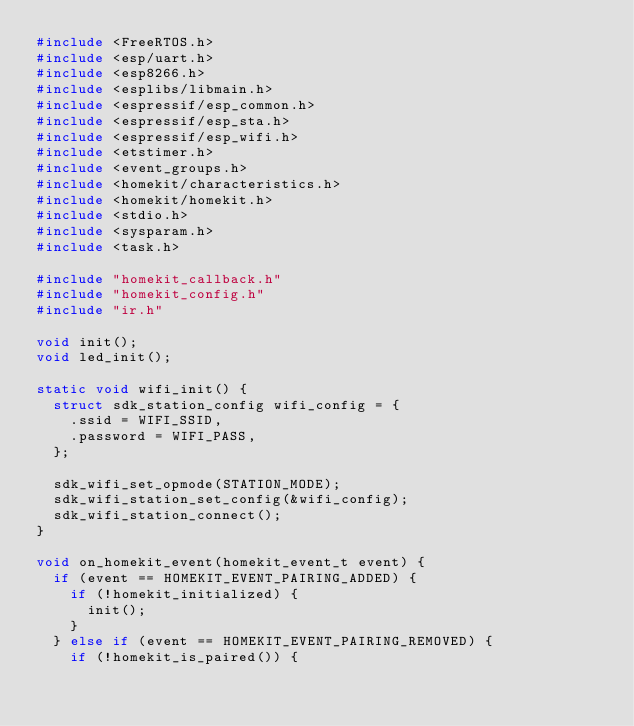<code> <loc_0><loc_0><loc_500><loc_500><_C_>#include <FreeRTOS.h>
#include <esp/uart.h>
#include <esp8266.h>
#include <esplibs/libmain.h>
#include <espressif/esp_common.h>
#include <espressif/esp_sta.h>
#include <espressif/esp_wifi.h>
#include <etstimer.h>
#include <event_groups.h>
#include <homekit/characteristics.h>
#include <homekit/homekit.h>
#include <stdio.h>
#include <sysparam.h>
#include <task.h>

#include "homekit_callback.h"
#include "homekit_config.h"
#include "ir.h"

void init();
void led_init();

static void wifi_init() {
  struct sdk_station_config wifi_config = {
    .ssid = WIFI_SSID,
    .password = WIFI_PASS,
  };

  sdk_wifi_set_opmode(STATION_MODE);
  sdk_wifi_station_set_config(&wifi_config);
  sdk_wifi_station_connect();
}

void on_homekit_event(homekit_event_t event) {
  if (event == HOMEKIT_EVENT_PAIRING_ADDED) {
    if (!homekit_initialized) {
      init();
    }
  } else if (event == HOMEKIT_EVENT_PAIRING_REMOVED) {
    if (!homekit_is_paired()) {</code> 